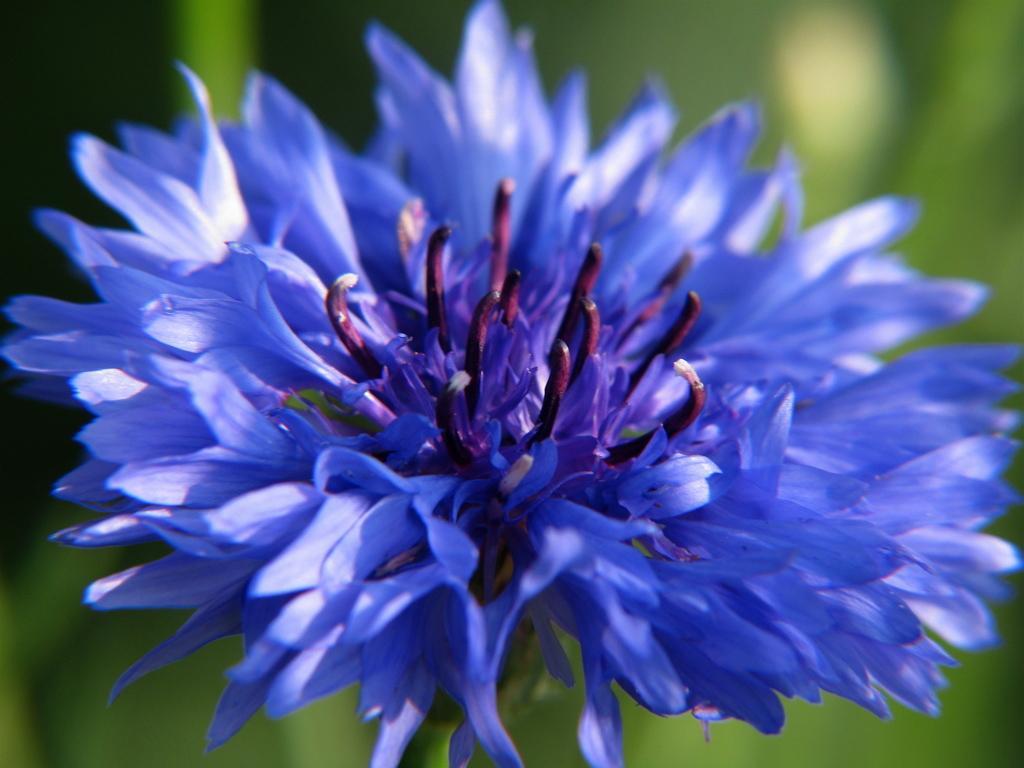Describe this image in one or two sentences. In this picture we can observe a blue color flower. There are violet color buds on the flower. The background is in green color. 